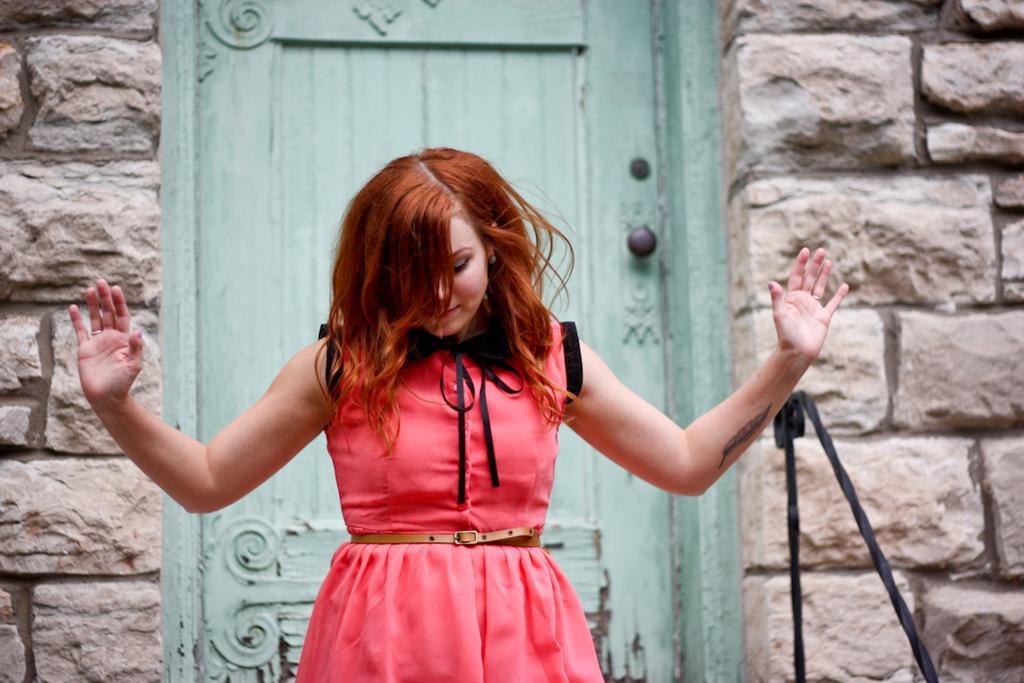Could you give a brief overview of what you see in this image? In this image there is a lady standing in front of the door, a stone wall and a black color pole. 